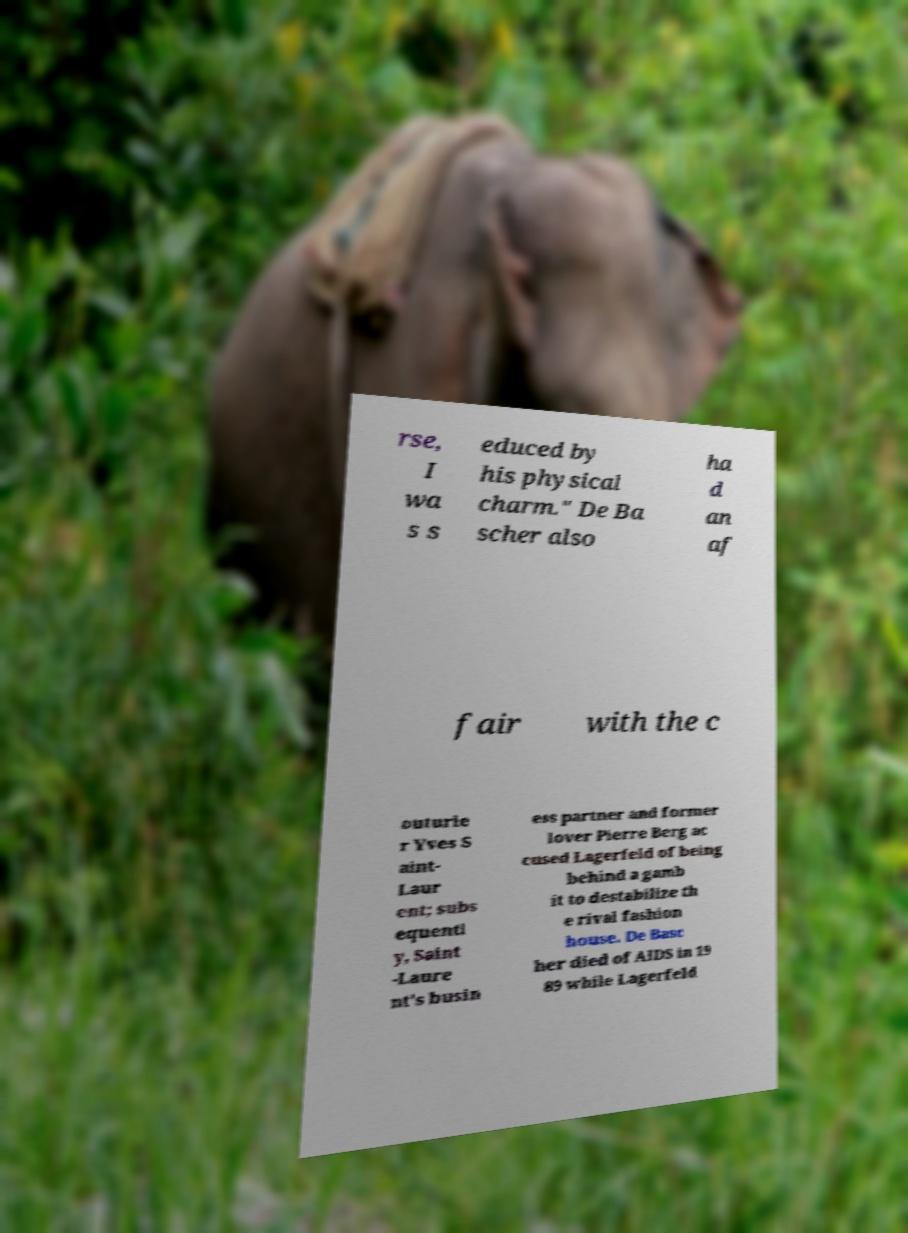Could you assist in decoding the text presented in this image and type it out clearly? rse, I wa s s educed by his physical charm." De Ba scher also ha d an af fair with the c outurie r Yves S aint- Laur ent; subs equentl y, Saint -Laure nt's busin ess partner and former lover Pierre Berg ac cused Lagerfeld of being behind a gamb it to destabilize th e rival fashion house. De Basc her died of AIDS in 19 89 while Lagerfeld 